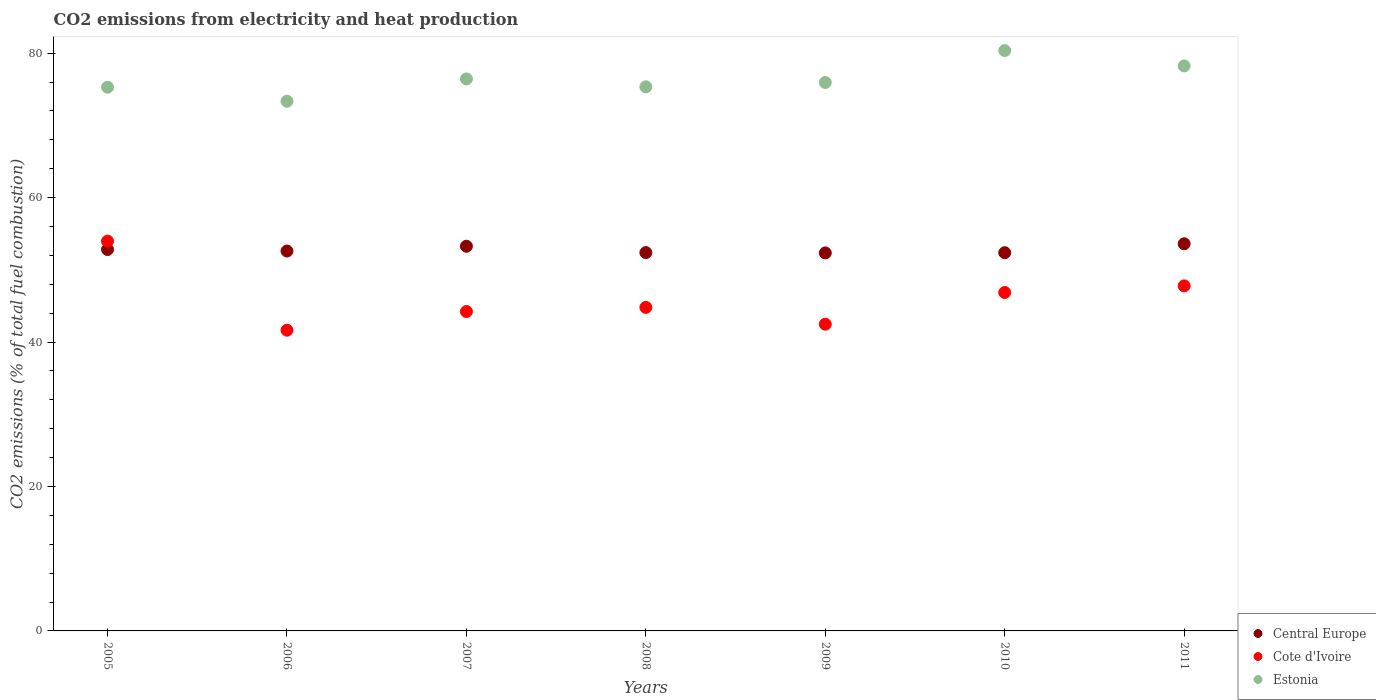How many different coloured dotlines are there?
Provide a short and direct response. 3. Is the number of dotlines equal to the number of legend labels?
Your answer should be compact. Yes. What is the amount of CO2 emitted in Central Europe in 2007?
Ensure brevity in your answer.  53.26. Across all years, what is the maximum amount of CO2 emitted in Central Europe?
Ensure brevity in your answer.  53.6. Across all years, what is the minimum amount of CO2 emitted in Cote d'Ivoire?
Your response must be concise. 41.64. In which year was the amount of CO2 emitted in Central Europe maximum?
Your answer should be compact. 2011. What is the total amount of CO2 emitted in Estonia in the graph?
Provide a short and direct response. 534.91. What is the difference between the amount of CO2 emitted in Central Europe in 2007 and that in 2011?
Offer a terse response. -0.34. What is the difference between the amount of CO2 emitted in Cote d'Ivoire in 2008 and the amount of CO2 emitted in Estonia in 2007?
Make the answer very short. -31.63. What is the average amount of CO2 emitted in Central Europe per year?
Provide a short and direct response. 52.77. In the year 2010, what is the difference between the amount of CO2 emitted in Estonia and amount of CO2 emitted in Central Europe?
Your answer should be very brief. 27.99. In how many years, is the amount of CO2 emitted in Estonia greater than 56 %?
Ensure brevity in your answer.  7. What is the ratio of the amount of CO2 emitted in Central Europe in 2005 to that in 2008?
Ensure brevity in your answer.  1.01. Is the amount of CO2 emitted in Cote d'Ivoire in 2009 less than that in 2010?
Offer a very short reply. Yes. Is the difference between the amount of CO2 emitted in Estonia in 2005 and 2009 greater than the difference between the amount of CO2 emitted in Central Europe in 2005 and 2009?
Offer a terse response. No. What is the difference between the highest and the second highest amount of CO2 emitted in Cote d'Ivoire?
Your answer should be very brief. 6.19. What is the difference between the highest and the lowest amount of CO2 emitted in Estonia?
Provide a short and direct response. 7.02. Is the sum of the amount of CO2 emitted in Estonia in 2005 and 2008 greater than the maximum amount of CO2 emitted in Cote d'Ivoire across all years?
Your answer should be very brief. Yes. Is it the case that in every year, the sum of the amount of CO2 emitted in Estonia and amount of CO2 emitted in Cote d'Ivoire  is greater than the amount of CO2 emitted in Central Europe?
Provide a succinct answer. Yes. Does the amount of CO2 emitted in Cote d'Ivoire monotonically increase over the years?
Keep it short and to the point. No. Is the amount of CO2 emitted in Central Europe strictly greater than the amount of CO2 emitted in Estonia over the years?
Give a very brief answer. No. What is the difference between two consecutive major ticks on the Y-axis?
Your answer should be compact. 20. Does the graph contain any zero values?
Provide a short and direct response. No. Where does the legend appear in the graph?
Ensure brevity in your answer.  Bottom right. What is the title of the graph?
Make the answer very short. CO2 emissions from electricity and heat production. What is the label or title of the X-axis?
Offer a very short reply. Years. What is the label or title of the Y-axis?
Provide a succinct answer. CO2 emissions (% of total fuel combustion). What is the CO2 emissions (% of total fuel combustion) in Central Europe in 2005?
Provide a succinct answer. 52.81. What is the CO2 emissions (% of total fuel combustion) in Cote d'Ivoire in 2005?
Make the answer very short. 53.97. What is the CO2 emissions (% of total fuel combustion) in Estonia in 2005?
Offer a terse response. 75.28. What is the CO2 emissions (% of total fuel combustion) in Central Europe in 2006?
Provide a succinct answer. 52.6. What is the CO2 emissions (% of total fuel combustion) of Cote d'Ivoire in 2006?
Your response must be concise. 41.64. What is the CO2 emissions (% of total fuel combustion) of Estonia in 2006?
Provide a short and direct response. 73.34. What is the CO2 emissions (% of total fuel combustion) of Central Europe in 2007?
Provide a succinct answer. 53.26. What is the CO2 emissions (% of total fuel combustion) of Cote d'Ivoire in 2007?
Ensure brevity in your answer.  44.22. What is the CO2 emissions (% of total fuel combustion) in Estonia in 2007?
Give a very brief answer. 76.43. What is the CO2 emissions (% of total fuel combustion) in Central Europe in 2008?
Your answer should be compact. 52.38. What is the CO2 emissions (% of total fuel combustion) of Cote d'Ivoire in 2008?
Provide a succinct answer. 44.79. What is the CO2 emissions (% of total fuel combustion) of Estonia in 2008?
Offer a very short reply. 75.34. What is the CO2 emissions (% of total fuel combustion) of Central Europe in 2009?
Give a very brief answer. 52.34. What is the CO2 emissions (% of total fuel combustion) in Cote d'Ivoire in 2009?
Give a very brief answer. 42.47. What is the CO2 emissions (% of total fuel combustion) of Estonia in 2009?
Provide a succinct answer. 75.94. What is the CO2 emissions (% of total fuel combustion) in Central Europe in 2010?
Keep it short and to the point. 52.37. What is the CO2 emissions (% of total fuel combustion) in Cote d'Ivoire in 2010?
Offer a terse response. 46.86. What is the CO2 emissions (% of total fuel combustion) of Estonia in 2010?
Provide a succinct answer. 80.36. What is the CO2 emissions (% of total fuel combustion) in Central Europe in 2011?
Your answer should be very brief. 53.6. What is the CO2 emissions (% of total fuel combustion) in Cote d'Ivoire in 2011?
Offer a very short reply. 47.77. What is the CO2 emissions (% of total fuel combustion) in Estonia in 2011?
Provide a succinct answer. 78.23. Across all years, what is the maximum CO2 emissions (% of total fuel combustion) in Central Europe?
Keep it short and to the point. 53.6. Across all years, what is the maximum CO2 emissions (% of total fuel combustion) of Cote d'Ivoire?
Your response must be concise. 53.97. Across all years, what is the maximum CO2 emissions (% of total fuel combustion) in Estonia?
Keep it short and to the point. 80.36. Across all years, what is the minimum CO2 emissions (% of total fuel combustion) of Central Europe?
Provide a short and direct response. 52.34. Across all years, what is the minimum CO2 emissions (% of total fuel combustion) of Cote d'Ivoire?
Make the answer very short. 41.64. Across all years, what is the minimum CO2 emissions (% of total fuel combustion) in Estonia?
Offer a very short reply. 73.34. What is the total CO2 emissions (% of total fuel combustion) in Central Europe in the graph?
Provide a succinct answer. 369.37. What is the total CO2 emissions (% of total fuel combustion) in Cote d'Ivoire in the graph?
Provide a succinct answer. 321.73. What is the total CO2 emissions (% of total fuel combustion) of Estonia in the graph?
Provide a short and direct response. 534.91. What is the difference between the CO2 emissions (% of total fuel combustion) of Central Europe in 2005 and that in 2006?
Provide a succinct answer. 0.21. What is the difference between the CO2 emissions (% of total fuel combustion) of Cote d'Ivoire in 2005 and that in 2006?
Give a very brief answer. 12.33. What is the difference between the CO2 emissions (% of total fuel combustion) of Estonia in 2005 and that in 2006?
Offer a terse response. 1.94. What is the difference between the CO2 emissions (% of total fuel combustion) of Central Europe in 2005 and that in 2007?
Your response must be concise. -0.45. What is the difference between the CO2 emissions (% of total fuel combustion) in Cote d'Ivoire in 2005 and that in 2007?
Offer a terse response. 9.74. What is the difference between the CO2 emissions (% of total fuel combustion) of Estonia in 2005 and that in 2007?
Provide a short and direct response. -1.15. What is the difference between the CO2 emissions (% of total fuel combustion) of Central Europe in 2005 and that in 2008?
Provide a short and direct response. 0.43. What is the difference between the CO2 emissions (% of total fuel combustion) of Cote d'Ivoire in 2005 and that in 2008?
Keep it short and to the point. 9.17. What is the difference between the CO2 emissions (% of total fuel combustion) of Estonia in 2005 and that in 2008?
Offer a very short reply. -0.06. What is the difference between the CO2 emissions (% of total fuel combustion) in Central Europe in 2005 and that in 2009?
Your answer should be very brief. 0.47. What is the difference between the CO2 emissions (% of total fuel combustion) in Cote d'Ivoire in 2005 and that in 2009?
Ensure brevity in your answer.  11.5. What is the difference between the CO2 emissions (% of total fuel combustion) in Estonia in 2005 and that in 2009?
Provide a succinct answer. -0.66. What is the difference between the CO2 emissions (% of total fuel combustion) in Central Europe in 2005 and that in 2010?
Ensure brevity in your answer.  0.44. What is the difference between the CO2 emissions (% of total fuel combustion) in Cote d'Ivoire in 2005 and that in 2010?
Provide a succinct answer. 7.11. What is the difference between the CO2 emissions (% of total fuel combustion) in Estonia in 2005 and that in 2010?
Provide a short and direct response. -5.08. What is the difference between the CO2 emissions (% of total fuel combustion) in Central Europe in 2005 and that in 2011?
Provide a short and direct response. -0.8. What is the difference between the CO2 emissions (% of total fuel combustion) in Cote d'Ivoire in 2005 and that in 2011?
Your answer should be very brief. 6.19. What is the difference between the CO2 emissions (% of total fuel combustion) in Estonia in 2005 and that in 2011?
Provide a short and direct response. -2.95. What is the difference between the CO2 emissions (% of total fuel combustion) in Central Europe in 2006 and that in 2007?
Ensure brevity in your answer.  -0.66. What is the difference between the CO2 emissions (% of total fuel combustion) in Cote d'Ivoire in 2006 and that in 2007?
Make the answer very short. -2.59. What is the difference between the CO2 emissions (% of total fuel combustion) of Estonia in 2006 and that in 2007?
Ensure brevity in your answer.  -3.09. What is the difference between the CO2 emissions (% of total fuel combustion) in Central Europe in 2006 and that in 2008?
Your answer should be compact. 0.22. What is the difference between the CO2 emissions (% of total fuel combustion) of Cote d'Ivoire in 2006 and that in 2008?
Make the answer very short. -3.16. What is the difference between the CO2 emissions (% of total fuel combustion) in Estonia in 2006 and that in 2008?
Provide a short and direct response. -2. What is the difference between the CO2 emissions (% of total fuel combustion) of Central Europe in 2006 and that in 2009?
Offer a very short reply. 0.26. What is the difference between the CO2 emissions (% of total fuel combustion) in Cote d'Ivoire in 2006 and that in 2009?
Provide a short and direct response. -0.83. What is the difference between the CO2 emissions (% of total fuel combustion) in Estonia in 2006 and that in 2009?
Make the answer very short. -2.6. What is the difference between the CO2 emissions (% of total fuel combustion) in Central Europe in 2006 and that in 2010?
Give a very brief answer. 0.23. What is the difference between the CO2 emissions (% of total fuel combustion) in Cote d'Ivoire in 2006 and that in 2010?
Keep it short and to the point. -5.22. What is the difference between the CO2 emissions (% of total fuel combustion) in Estonia in 2006 and that in 2010?
Offer a terse response. -7.02. What is the difference between the CO2 emissions (% of total fuel combustion) in Central Europe in 2006 and that in 2011?
Offer a very short reply. -1. What is the difference between the CO2 emissions (% of total fuel combustion) of Cote d'Ivoire in 2006 and that in 2011?
Provide a short and direct response. -6.14. What is the difference between the CO2 emissions (% of total fuel combustion) in Estonia in 2006 and that in 2011?
Keep it short and to the point. -4.89. What is the difference between the CO2 emissions (% of total fuel combustion) of Central Europe in 2007 and that in 2008?
Ensure brevity in your answer.  0.88. What is the difference between the CO2 emissions (% of total fuel combustion) of Cote d'Ivoire in 2007 and that in 2008?
Offer a very short reply. -0.57. What is the difference between the CO2 emissions (% of total fuel combustion) in Estonia in 2007 and that in 2008?
Your answer should be compact. 1.09. What is the difference between the CO2 emissions (% of total fuel combustion) of Central Europe in 2007 and that in 2009?
Make the answer very short. 0.92. What is the difference between the CO2 emissions (% of total fuel combustion) in Cote d'Ivoire in 2007 and that in 2009?
Keep it short and to the point. 1.75. What is the difference between the CO2 emissions (% of total fuel combustion) in Estonia in 2007 and that in 2009?
Offer a very short reply. 0.49. What is the difference between the CO2 emissions (% of total fuel combustion) in Central Europe in 2007 and that in 2010?
Provide a succinct answer. 0.89. What is the difference between the CO2 emissions (% of total fuel combustion) of Cote d'Ivoire in 2007 and that in 2010?
Offer a very short reply. -2.64. What is the difference between the CO2 emissions (% of total fuel combustion) of Estonia in 2007 and that in 2010?
Your answer should be compact. -3.93. What is the difference between the CO2 emissions (% of total fuel combustion) of Central Europe in 2007 and that in 2011?
Offer a very short reply. -0.34. What is the difference between the CO2 emissions (% of total fuel combustion) in Cote d'Ivoire in 2007 and that in 2011?
Provide a short and direct response. -3.55. What is the difference between the CO2 emissions (% of total fuel combustion) of Estonia in 2007 and that in 2011?
Make the answer very short. -1.8. What is the difference between the CO2 emissions (% of total fuel combustion) in Central Europe in 2008 and that in 2009?
Your response must be concise. 0.04. What is the difference between the CO2 emissions (% of total fuel combustion) in Cote d'Ivoire in 2008 and that in 2009?
Offer a very short reply. 2.32. What is the difference between the CO2 emissions (% of total fuel combustion) of Estonia in 2008 and that in 2009?
Offer a terse response. -0.6. What is the difference between the CO2 emissions (% of total fuel combustion) in Central Europe in 2008 and that in 2010?
Keep it short and to the point. 0.01. What is the difference between the CO2 emissions (% of total fuel combustion) in Cote d'Ivoire in 2008 and that in 2010?
Offer a very short reply. -2.06. What is the difference between the CO2 emissions (% of total fuel combustion) of Estonia in 2008 and that in 2010?
Your answer should be compact. -5.02. What is the difference between the CO2 emissions (% of total fuel combustion) in Central Europe in 2008 and that in 2011?
Offer a terse response. -1.22. What is the difference between the CO2 emissions (% of total fuel combustion) in Cote d'Ivoire in 2008 and that in 2011?
Make the answer very short. -2.98. What is the difference between the CO2 emissions (% of total fuel combustion) of Estonia in 2008 and that in 2011?
Make the answer very short. -2.89. What is the difference between the CO2 emissions (% of total fuel combustion) in Central Europe in 2009 and that in 2010?
Your response must be concise. -0.03. What is the difference between the CO2 emissions (% of total fuel combustion) of Cote d'Ivoire in 2009 and that in 2010?
Offer a terse response. -4.39. What is the difference between the CO2 emissions (% of total fuel combustion) of Estonia in 2009 and that in 2010?
Give a very brief answer. -4.42. What is the difference between the CO2 emissions (% of total fuel combustion) of Central Europe in 2009 and that in 2011?
Your response must be concise. -1.26. What is the difference between the CO2 emissions (% of total fuel combustion) of Cote d'Ivoire in 2009 and that in 2011?
Make the answer very short. -5.3. What is the difference between the CO2 emissions (% of total fuel combustion) of Estonia in 2009 and that in 2011?
Your answer should be very brief. -2.29. What is the difference between the CO2 emissions (% of total fuel combustion) in Central Europe in 2010 and that in 2011?
Keep it short and to the point. -1.23. What is the difference between the CO2 emissions (% of total fuel combustion) in Cote d'Ivoire in 2010 and that in 2011?
Your answer should be compact. -0.91. What is the difference between the CO2 emissions (% of total fuel combustion) in Estonia in 2010 and that in 2011?
Ensure brevity in your answer.  2.13. What is the difference between the CO2 emissions (% of total fuel combustion) in Central Europe in 2005 and the CO2 emissions (% of total fuel combustion) in Cote d'Ivoire in 2006?
Provide a succinct answer. 11.17. What is the difference between the CO2 emissions (% of total fuel combustion) in Central Europe in 2005 and the CO2 emissions (% of total fuel combustion) in Estonia in 2006?
Offer a very short reply. -20.53. What is the difference between the CO2 emissions (% of total fuel combustion) of Cote d'Ivoire in 2005 and the CO2 emissions (% of total fuel combustion) of Estonia in 2006?
Offer a terse response. -19.38. What is the difference between the CO2 emissions (% of total fuel combustion) of Central Europe in 2005 and the CO2 emissions (% of total fuel combustion) of Cote d'Ivoire in 2007?
Make the answer very short. 8.58. What is the difference between the CO2 emissions (% of total fuel combustion) of Central Europe in 2005 and the CO2 emissions (% of total fuel combustion) of Estonia in 2007?
Make the answer very short. -23.62. What is the difference between the CO2 emissions (% of total fuel combustion) of Cote d'Ivoire in 2005 and the CO2 emissions (% of total fuel combustion) of Estonia in 2007?
Offer a very short reply. -22.46. What is the difference between the CO2 emissions (% of total fuel combustion) in Central Europe in 2005 and the CO2 emissions (% of total fuel combustion) in Cote d'Ivoire in 2008?
Give a very brief answer. 8.01. What is the difference between the CO2 emissions (% of total fuel combustion) of Central Europe in 2005 and the CO2 emissions (% of total fuel combustion) of Estonia in 2008?
Provide a short and direct response. -22.53. What is the difference between the CO2 emissions (% of total fuel combustion) in Cote d'Ivoire in 2005 and the CO2 emissions (% of total fuel combustion) in Estonia in 2008?
Offer a very short reply. -21.37. What is the difference between the CO2 emissions (% of total fuel combustion) of Central Europe in 2005 and the CO2 emissions (% of total fuel combustion) of Cote d'Ivoire in 2009?
Ensure brevity in your answer.  10.34. What is the difference between the CO2 emissions (% of total fuel combustion) of Central Europe in 2005 and the CO2 emissions (% of total fuel combustion) of Estonia in 2009?
Keep it short and to the point. -23.13. What is the difference between the CO2 emissions (% of total fuel combustion) of Cote d'Ivoire in 2005 and the CO2 emissions (% of total fuel combustion) of Estonia in 2009?
Give a very brief answer. -21.97. What is the difference between the CO2 emissions (% of total fuel combustion) in Central Europe in 2005 and the CO2 emissions (% of total fuel combustion) in Cote d'Ivoire in 2010?
Ensure brevity in your answer.  5.95. What is the difference between the CO2 emissions (% of total fuel combustion) in Central Europe in 2005 and the CO2 emissions (% of total fuel combustion) in Estonia in 2010?
Your answer should be compact. -27.55. What is the difference between the CO2 emissions (% of total fuel combustion) in Cote d'Ivoire in 2005 and the CO2 emissions (% of total fuel combustion) in Estonia in 2010?
Give a very brief answer. -26.39. What is the difference between the CO2 emissions (% of total fuel combustion) of Central Europe in 2005 and the CO2 emissions (% of total fuel combustion) of Cote d'Ivoire in 2011?
Ensure brevity in your answer.  5.03. What is the difference between the CO2 emissions (% of total fuel combustion) in Central Europe in 2005 and the CO2 emissions (% of total fuel combustion) in Estonia in 2011?
Offer a terse response. -25.42. What is the difference between the CO2 emissions (% of total fuel combustion) in Cote d'Ivoire in 2005 and the CO2 emissions (% of total fuel combustion) in Estonia in 2011?
Your answer should be compact. -24.26. What is the difference between the CO2 emissions (% of total fuel combustion) of Central Europe in 2006 and the CO2 emissions (% of total fuel combustion) of Cote d'Ivoire in 2007?
Your answer should be compact. 8.38. What is the difference between the CO2 emissions (% of total fuel combustion) in Central Europe in 2006 and the CO2 emissions (% of total fuel combustion) in Estonia in 2007?
Keep it short and to the point. -23.83. What is the difference between the CO2 emissions (% of total fuel combustion) of Cote d'Ivoire in 2006 and the CO2 emissions (% of total fuel combustion) of Estonia in 2007?
Offer a terse response. -34.79. What is the difference between the CO2 emissions (% of total fuel combustion) in Central Europe in 2006 and the CO2 emissions (% of total fuel combustion) in Cote d'Ivoire in 2008?
Offer a terse response. 7.8. What is the difference between the CO2 emissions (% of total fuel combustion) in Central Europe in 2006 and the CO2 emissions (% of total fuel combustion) in Estonia in 2008?
Offer a terse response. -22.74. What is the difference between the CO2 emissions (% of total fuel combustion) in Cote d'Ivoire in 2006 and the CO2 emissions (% of total fuel combustion) in Estonia in 2008?
Your answer should be very brief. -33.7. What is the difference between the CO2 emissions (% of total fuel combustion) in Central Europe in 2006 and the CO2 emissions (% of total fuel combustion) in Cote d'Ivoire in 2009?
Your answer should be very brief. 10.13. What is the difference between the CO2 emissions (% of total fuel combustion) in Central Europe in 2006 and the CO2 emissions (% of total fuel combustion) in Estonia in 2009?
Provide a short and direct response. -23.34. What is the difference between the CO2 emissions (% of total fuel combustion) in Cote d'Ivoire in 2006 and the CO2 emissions (% of total fuel combustion) in Estonia in 2009?
Offer a terse response. -34.3. What is the difference between the CO2 emissions (% of total fuel combustion) in Central Europe in 2006 and the CO2 emissions (% of total fuel combustion) in Cote d'Ivoire in 2010?
Your answer should be compact. 5.74. What is the difference between the CO2 emissions (% of total fuel combustion) of Central Europe in 2006 and the CO2 emissions (% of total fuel combustion) of Estonia in 2010?
Give a very brief answer. -27.76. What is the difference between the CO2 emissions (% of total fuel combustion) in Cote d'Ivoire in 2006 and the CO2 emissions (% of total fuel combustion) in Estonia in 2010?
Make the answer very short. -38.72. What is the difference between the CO2 emissions (% of total fuel combustion) in Central Europe in 2006 and the CO2 emissions (% of total fuel combustion) in Cote d'Ivoire in 2011?
Provide a short and direct response. 4.83. What is the difference between the CO2 emissions (% of total fuel combustion) in Central Europe in 2006 and the CO2 emissions (% of total fuel combustion) in Estonia in 2011?
Offer a very short reply. -25.63. What is the difference between the CO2 emissions (% of total fuel combustion) in Cote d'Ivoire in 2006 and the CO2 emissions (% of total fuel combustion) in Estonia in 2011?
Provide a short and direct response. -36.59. What is the difference between the CO2 emissions (% of total fuel combustion) of Central Europe in 2007 and the CO2 emissions (% of total fuel combustion) of Cote d'Ivoire in 2008?
Provide a succinct answer. 8.47. What is the difference between the CO2 emissions (% of total fuel combustion) in Central Europe in 2007 and the CO2 emissions (% of total fuel combustion) in Estonia in 2008?
Ensure brevity in your answer.  -22.08. What is the difference between the CO2 emissions (% of total fuel combustion) of Cote d'Ivoire in 2007 and the CO2 emissions (% of total fuel combustion) of Estonia in 2008?
Ensure brevity in your answer.  -31.11. What is the difference between the CO2 emissions (% of total fuel combustion) of Central Europe in 2007 and the CO2 emissions (% of total fuel combustion) of Cote d'Ivoire in 2009?
Offer a terse response. 10.79. What is the difference between the CO2 emissions (% of total fuel combustion) of Central Europe in 2007 and the CO2 emissions (% of total fuel combustion) of Estonia in 2009?
Your response must be concise. -22.68. What is the difference between the CO2 emissions (% of total fuel combustion) in Cote d'Ivoire in 2007 and the CO2 emissions (% of total fuel combustion) in Estonia in 2009?
Your answer should be very brief. -31.71. What is the difference between the CO2 emissions (% of total fuel combustion) of Central Europe in 2007 and the CO2 emissions (% of total fuel combustion) of Cote d'Ivoire in 2010?
Offer a very short reply. 6.4. What is the difference between the CO2 emissions (% of total fuel combustion) in Central Europe in 2007 and the CO2 emissions (% of total fuel combustion) in Estonia in 2010?
Give a very brief answer. -27.1. What is the difference between the CO2 emissions (% of total fuel combustion) of Cote d'Ivoire in 2007 and the CO2 emissions (% of total fuel combustion) of Estonia in 2010?
Your answer should be very brief. -36.13. What is the difference between the CO2 emissions (% of total fuel combustion) of Central Europe in 2007 and the CO2 emissions (% of total fuel combustion) of Cote d'Ivoire in 2011?
Your answer should be very brief. 5.49. What is the difference between the CO2 emissions (% of total fuel combustion) in Central Europe in 2007 and the CO2 emissions (% of total fuel combustion) in Estonia in 2011?
Your response must be concise. -24.97. What is the difference between the CO2 emissions (% of total fuel combustion) of Cote d'Ivoire in 2007 and the CO2 emissions (% of total fuel combustion) of Estonia in 2011?
Provide a short and direct response. -34. What is the difference between the CO2 emissions (% of total fuel combustion) of Central Europe in 2008 and the CO2 emissions (% of total fuel combustion) of Cote d'Ivoire in 2009?
Make the answer very short. 9.91. What is the difference between the CO2 emissions (% of total fuel combustion) in Central Europe in 2008 and the CO2 emissions (% of total fuel combustion) in Estonia in 2009?
Your response must be concise. -23.56. What is the difference between the CO2 emissions (% of total fuel combustion) in Cote d'Ivoire in 2008 and the CO2 emissions (% of total fuel combustion) in Estonia in 2009?
Your answer should be very brief. -31.14. What is the difference between the CO2 emissions (% of total fuel combustion) of Central Europe in 2008 and the CO2 emissions (% of total fuel combustion) of Cote d'Ivoire in 2010?
Offer a very short reply. 5.52. What is the difference between the CO2 emissions (% of total fuel combustion) in Central Europe in 2008 and the CO2 emissions (% of total fuel combustion) in Estonia in 2010?
Keep it short and to the point. -27.97. What is the difference between the CO2 emissions (% of total fuel combustion) of Cote d'Ivoire in 2008 and the CO2 emissions (% of total fuel combustion) of Estonia in 2010?
Keep it short and to the point. -35.56. What is the difference between the CO2 emissions (% of total fuel combustion) of Central Europe in 2008 and the CO2 emissions (% of total fuel combustion) of Cote d'Ivoire in 2011?
Provide a succinct answer. 4.61. What is the difference between the CO2 emissions (% of total fuel combustion) of Central Europe in 2008 and the CO2 emissions (% of total fuel combustion) of Estonia in 2011?
Provide a short and direct response. -25.85. What is the difference between the CO2 emissions (% of total fuel combustion) in Cote d'Ivoire in 2008 and the CO2 emissions (% of total fuel combustion) in Estonia in 2011?
Offer a terse response. -33.43. What is the difference between the CO2 emissions (% of total fuel combustion) of Central Europe in 2009 and the CO2 emissions (% of total fuel combustion) of Cote d'Ivoire in 2010?
Offer a very short reply. 5.48. What is the difference between the CO2 emissions (% of total fuel combustion) in Central Europe in 2009 and the CO2 emissions (% of total fuel combustion) in Estonia in 2010?
Ensure brevity in your answer.  -28.02. What is the difference between the CO2 emissions (% of total fuel combustion) of Cote d'Ivoire in 2009 and the CO2 emissions (% of total fuel combustion) of Estonia in 2010?
Keep it short and to the point. -37.89. What is the difference between the CO2 emissions (% of total fuel combustion) of Central Europe in 2009 and the CO2 emissions (% of total fuel combustion) of Cote d'Ivoire in 2011?
Your response must be concise. 4.57. What is the difference between the CO2 emissions (% of total fuel combustion) in Central Europe in 2009 and the CO2 emissions (% of total fuel combustion) in Estonia in 2011?
Your response must be concise. -25.89. What is the difference between the CO2 emissions (% of total fuel combustion) in Cote d'Ivoire in 2009 and the CO2 emissions (% of total fuel combustion) in Estonia in 2011?
Offer a very short reply. -35.76. What is the difference between the CO2 emissions (% of total fuel combustion) of Central Europe in 2010 and the CO2 emissions (% of total fuel combustion) of Cote d'Ivoire in 2011?
Make the answer very short. 4.6. What is the difference between the CO2 emissions (% of total fuel combustion) in Central Europe in 2010 and the CO2 emissions (% of total fuel combustion) in Estonia in 2011?
Ensure brevity in your answer.  -25.86. What is the difference between the CO2 emissions (% of total fuel combustion) of Cote d'Ivoire in 2010 and the CO2 emissions (% of total fuel combustion) of Estonia in 2011?
Ensure brevity in your answer.  -31.37. What is the average CO2 emissions (% of total fuel combustion) of Central Europe per year?
Ensure brevity in your answer.  52.77. What is the average CO2 emissions (% of total fuel combustion) of Cote d'Ivoire per year?
Offer a terse response. 45.96. What is the average CO2 emissions (% of total fuel combustion) in Estonia per year?
Keep it short and to the point. 76.42. In the year 2005, what is the difference between the CO2 emissions (% of total fuel combustion) in Central Europe and CO2 emissions (% of total fuel combustion) in Cote d'Ivoire?
Ensure brevity in your answer.  -1.16. In the year 2005, what is the difference between the CO2 emissions (% of total fuel combustion) in Central Europe and CO2 emissions (% of total fuel combustion) in Estonia?
Make the answer very short. -22.47. In the year 2005, what is the difference between the CO2 emissions (% of total fuel combustion) in Cote d'Ivoire and CO2 emissions (% of total fuel combustion) in Estonia?
Ensure brevity in your answer.  -21.32. In the year 2006, what is the difference between the CO2 emissions (% of total fuel combustion) of Central Europe and CO2 emissions (% of total fuel combustion) of Cote d'Ivoire?
Offer a very short reply. 10.96. In the year 2006, what is the difference between the CO2 emissions (% of total fuel combustion) of Central Europe and CO2 emissions (% of total fuel combustion) of Estonia?
Your response must be concise. -20.74. In the year 2006, what is the difference between the CO2 emissions (% of total fuel combustion) of Cote d'Ivoire and CO2 emissions (% of total fuel combustion) of Estonia?
Offer a terse response. -31.7. In the year 2007, what is the difference between the CO2 emissions (% of total fuel combustion) in Central Europe and CO2 emissions (% of total fuel combustion) in Cote d'Ivoire?
Offer a terse response. 9.04. In the year 2007, what is the difference between the CO2 emissions (% of total fuel combustion) of Central Europe and CO2 emissions (% of total fuel combustion) of Estonia?
Offer a terse response. -23.17. In the year 2007, what is the difference between the CO2 emissions (% of total fuel combustion) in Cote d'Ivoire and CO2 emissions (% of total fuel combustion) in Estonia?
Your answer should be very brief. -32.2. In the year 2008, what is the difference between the CO2 emissions (% of total fuel combustion) in Central Europe and CO2 emissions (% of total fuel combustion) in Cote d'Ivoire?
Offer a very short reply. 7.59. In the year 2008, what is the difference between the CO2 emissions (% of total fuel combustion) in Central Europe and CO2 emissions (% of total fuel combustion) in Estonia?
Your answer should be very brief. -22.96. In the year 2008, what is the difference between the CO2 emissions (% of total fuel combustion) in Cote d'Ivoire and CO2 emissions (% of total fuel combustion) in Estonia?
Offer a terse response. -30.54. In the year 2009, what is the difference between the CO2 emissions (% of total fuel combustion) in Central Europe and CO2 emissions (% of total fuel combustion) in Cote d'Ivoire?
Offer a very short reply. 9.87. In the year 2009, what is the difference between the CO2 emissions (% of total fuel combustion) in Central Europe and CO2 emissions (% of total fuel combustion) in Estonia?
Make the answer very short. -23.6. In the year 2009, what is the difference between the CO2 emissions (% of total fuel combustion) of Cote d'Ivoire and CO2 emissions (% of total fuel combustion) of Estonia?
Give a very brief answer. -33.47. In the year 2010, what is the difference between the CO2 emissions (% of total fuel combustion) in Central Europe and CO2 emissions (% of total fuel combustion) in Cote d'Ivoire?
Make the answer very short. 5.51. In the year 2010, what is the difference between the CO2 emissions (% of total fuel combustion) in Central Europe and CO2 emissions (% of total fuel combustion) in Estonia?
Keep it short and to the point. -27.99. In the year 2010, what is the difference between the CO2 emissions (% of total fuel combustion) of Cote d'Ivoire and CO2 emissions (% of total fuel combustion) of Estonia?
Your answer should be very brief. -33.5. In the year 2011, what is the difference between the CO2 emissions (% of total fuel combustion) of Central Europe and CO2 emissions (% of total fuel combustion) of Cote d'Ivoire?
Keep it short and to the point. 5.83. In the year 2011, what is the difference between the CO2 emissions (% of total fuel combustion) of Central Europe and CO2 emissions (% of total fuel combustion) of Estonia?
Offer a very short reply. -24.62. In the year 2011, what is the difference between the CO2 emissions (% of total fuel combustion) of Cote d'Ivoire and CO2 emissions (% of total fuel combustion) of Estonia?
Your answer should be compact. -30.45. What is the ratio of the CO2 emissions (% of total fuel combustion) of Cote d'Ivoire in 2005 to that in 2006?
Keep it short and to the point. 1.3. What is the ratio of the CO2 emissions (% of total fuel combustion) in Estonia in 2005 to that in 2006?
Give a very brief answer. 1.03. What is the ratio of the CO2 emissions (% of total fuel combustion) of Central Europe in 2005 to that in 2007?
Give a very brief answer. 0.99. What is the ratio of the CO2 emissions (% of total fuel combustion) in Cote d'Ivoire in 2005 to that in 2007?
Offer a terse response. 1.22. What is the ratio of the CO2 emissions (% of total fuel combustion) in Central Europe in 2005 to that in 2008?
Keep it short and to the point. 1.01. What is the ratio of the CO2 emissions (% of total fuel combustion) of Cote d'Ivoire in 2005 to that in 2008?
Provide a succinct answer. 1.2. What is the ratio of the CO2 emissions (% of total fuel combustion) of Estonia in 2005 to that in 2008?
Make the answer very short. 1. What is the ratio of the CO2 emissions (% of total fuel combustion) in Cote d'Ivoire in 2005 to that in 2009?
Make the answer very short. 1.27. What is the ratio of the CO2 emissions (% of total fuel combustion) of Central Europe in 2005 to that in 2010?
Offer a very short reply. 1.01. What is the ratio of the CO2 emissions (% of total fuel combustion) of Cote d'Ivoire in 2005 to that in 2010?
Provide a succinct answer. 1.15. What is the ratio of the CO2 emissions (% of total fuel combustion) in Estonia in 2005 to that in 2010?
Ensure brevity in your answer.  0.94. What is the ratio of the CO2 emissions (% of total fuel combustion) of Central Europe in 2005 to that in 2011?
Give a very brief answer. 0.99. What is the ratio of the CO2 emissions (% of total fuel combustion) of Cote d'Ivoire in 2005 to that in 2011?
Your answer should be very brief. 1.13. What is the ratio of the CO2 emissions (% of total fuel combustion) in Estonia in 2005 to that in 2011?
Make the answer very short. 0.96. What is the ratio of the CO2 emissions (% of total fuel combustion) in Central Europe in 2006 to that in 2007?
Make the answer very short. 0.99. What is the ratio of the CO2 emissions (% of total fuel combustion) in Cote d'Ivoire in 2006 to that in 2007?
Ensure brevity in your answer.  0.94. What is the ratio of the CO2 emissions (% of total fuel combustion) of Estonia in 2006 to that in 2007?
Offer a very short reply. 0.96. What is the ratio of the CO2 emissions (% of total fuel combustion) of Central Europe in 2006 to that in 2008?
Keep it short and to the point. 1. What is the ratio of the CO2 emissions (% of total fuel combustion) of Cote d'Ivoire in 2006 to that in 2008?
Provide a succinct answer. 0.93. What is the ratio of the CO2 emissions (% of total fuel combustion) of Estonia in 2006 to that in 2008?
Provide a short and direct response. 0.97. What is the ratio of the CO2 emissions (% of total fuel combustion) of Cote d'Ivoire in 2006 to that in 2009?
Make the answer very short. 0.98. What is the ratio of the CO2 emissions (% of total fuel combustion) of Estonia in 2006 to that in 2009?
Your answer should be very brief. 0.97. What is the ratio of the CO2 emissions (% of total fuel combustion) of Central Europe in 2006 to that in 2010?
Keep it short and to the point. 1. What is the ratio of the CO2 emissions (% of total fuel combustion) of Cote d'Ivoire in 2006 to that in 2010?
Offer a very short reply. 0.89. What is the ratio of the CO2 emissions (% of total fuel combustion) in Estonia in 2006 to that in 2010?
Offer a very short reply. 0.91. What is the ratio of the CO2 emissions (% of total fuel combustion) of Central Europe in 2006 to that in 2011?
Your answer should be very brief. 0.98. What is the ratio of the CO2 emissions (% of total fuel combustion) of Cote d'Ivoire in 2006 to that in 2011?
Offer a terse response. 0.87. What is the ratio of the CO2 emissions (% of total fuel combustion) of Estonia in 2006 to that in 2011?
Your answer should be very brief. 0.94. What is the ratio of the CO2 emissions (% of total fuel combustion) in Central Europe in 2007 to that in 2008?
Ensure brevity in your answer.  1.02. What is the ratio of the CO2 emissions (% of total fuel combustion) in Cote d'Ivoire in 2007 to that in 2008?
Offer a terse response. 0.99. What is the ratio of the CO2 emissions (% of total fuel combustion) in Estonia in 2007 to that in 2008?
Keep it short and to the point. 1.01. What is the ratio of the CO2 emissions (% of total fuel combustion) of Central Europe in 2007 to that in 2009?
Ensure brevity in your answer.  1.02. What is the ratio of the CO2 emissions (% of total fuel combustion) of Cote d'Ivoire in 2007 to that in 2009?
Your answer should be very brief. 1.04. What is the ratio of the CO2 emissions (% of total fuel combustion) of Cote d'Ivoire in 2007 to that in 2010?
Give a very brief answer. 0.94. What is the ratio of the CO2 emissions (% of total fuel combustion) in Estonia in 2007 to that in 2010?
Keep it short and to the point. 0.95. What is the ratio of the CO2 emissions (% of total fuel combustion) in Cote d'Ivoire in 2007 to that in 2011?
Keep it short and to the point. 0.93. What is the ratio of the CO2 emissions (% of total fuel combustion) in Central Europe in 2008 to that in 2009?
Your answer should be very brief. 1. What is the ratio of the CO2 emissions (% of total fuel combustion) of Cote d'Ivoire in 2008 to that in 2009?
Your response must be concise. 1.05. What is the ratio of the CO2 emissions (% of total fuel combustion) in Central Europe in 2008 to that in 2010?
Ensure brevity in your answer.  1. What is the ratio of the CO2 emissions (% of total fuel combustion) in Cote d'Ivoire in 2008 to that in 2010?
Your answer should be very brief. 0.96. What is the ratio of the CO2 emissions (% of total fuel combustion) in Estonia in 2008 to that in 2010?
Offer a very short reply. 0.94. What is the ratio of the CO2 emissions (% of total fuel combustion) of Central Europe in 2008 to that in 2011?
Your answer should be compact. 0.98. What is the ratio of the CO2 emissions (% of total fuel combustion) in Cote d'Ivoire in 2008 to that in 2011?
Offer a terse response. 0.94. What is the ratio of the CO2 emissions (% of total fuel combustion) in Estonia in 2008 to that in 2011?
Make the answer very short. 0.96. What is the ratio of the CO2 emissions (% of total fuel combustion) in Central Europe in 2009 to that in 2010?
Your answer should be compact. 1. What is the ratio of the CO2 emissions (% of total fuel combustion) in Cote d'Ivoire in 2009 to that in 2010?
Offer a very short reply. 0.91. What is the ratio of the CO2 emissions (% of total fuel combustion) in Estonia in 2009 to that in 2010?
Make the answer very short. 0.94. What is the ratio of the CO2 emissions (% of total fuel combustion) of Central Europe in 2009 to that in 2011?
Your answer should be very brief. 0.98. What is the ratio of the CO2 emissions (% of total fuel combustion) in Cote d'Ivoire in 2009 to that in 2011?
Ensure brevity in your answer.  0.89. What is the ratio of the CO2 emissions (% of total fuel combustion) of Estonia in 2009 to that in 2011?
Offer a terse response. 0.97. What is the ratio of the CO2 emissions (% of total fuel combustion) of Cote d'Ivoire in 2010 to that in 2011?
Your response must be concise. 0.98. What is the ratio of the CO2 emissions (% of total fuel combustion) in Estonia in 2010 to that in 2011?
Your answer should be very brief. 1.03. What is the difference between the highest and the second highest CO2 emissions (% of total fuel combustion) of Central Europe?
Your response must be concise. 0.34. What is the difference between the highest and the second highest CO2 emissions (% of total fuel combustion) of Cote d'Ivoire?
Your response must be concise. 6.19. What is the difference between the highest and the second highest CO2 emissions (% of total fuel combustion) in Estonia?
Your response must be concise. 2.13. What is the difference between the highest and the lowest CO2 emissions (% of total fuel combustion) in Central Europe?
Provide a succinct answer. 1.26. What is the difference between the highest and the lowest CO2 emissions (% of total fuel combustion) of Cote d'Ivoire?
Provide a short and direct response. 12.33. What is the difference between the highest and the lowest CO2 emissions (% of total fuel combustion) of Estonia?
Give a very brief answer. 7.02. 